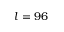<formula> <loc_0><loc_0><loc_500><loc_500>l = 9 6</formula> 